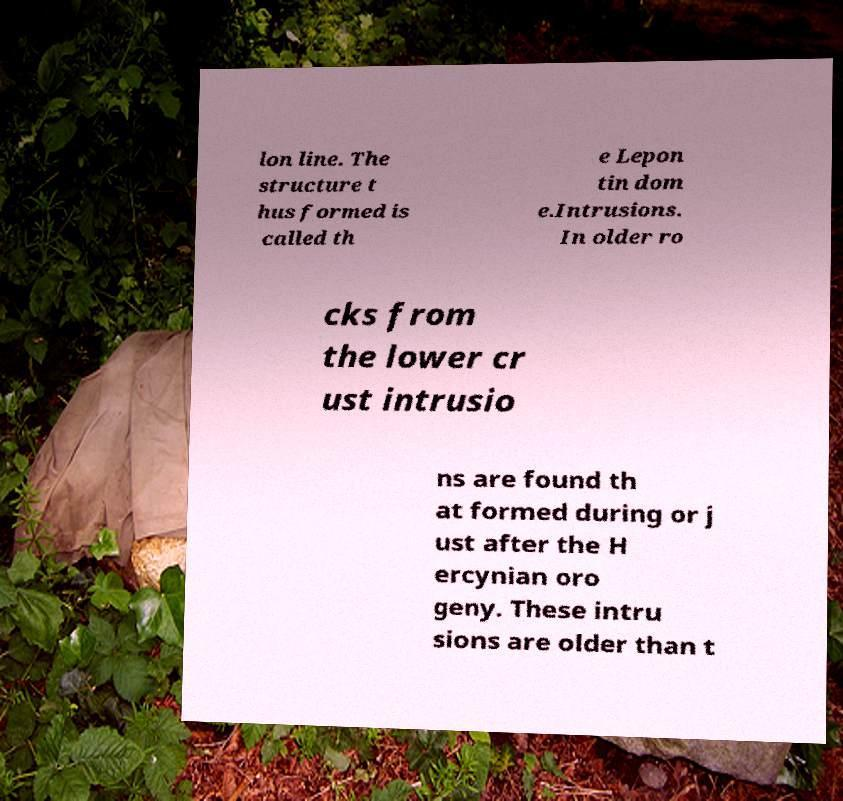Could you extract and type out the text from this image? lon line. The structure t hus formed is called th e Lepon tin dom e.Intrusions. In older ro cks from the lower cr ust intrusio ns are found th at formed during or j ust after the H ercynian oro geny. These intru sions are older than t 